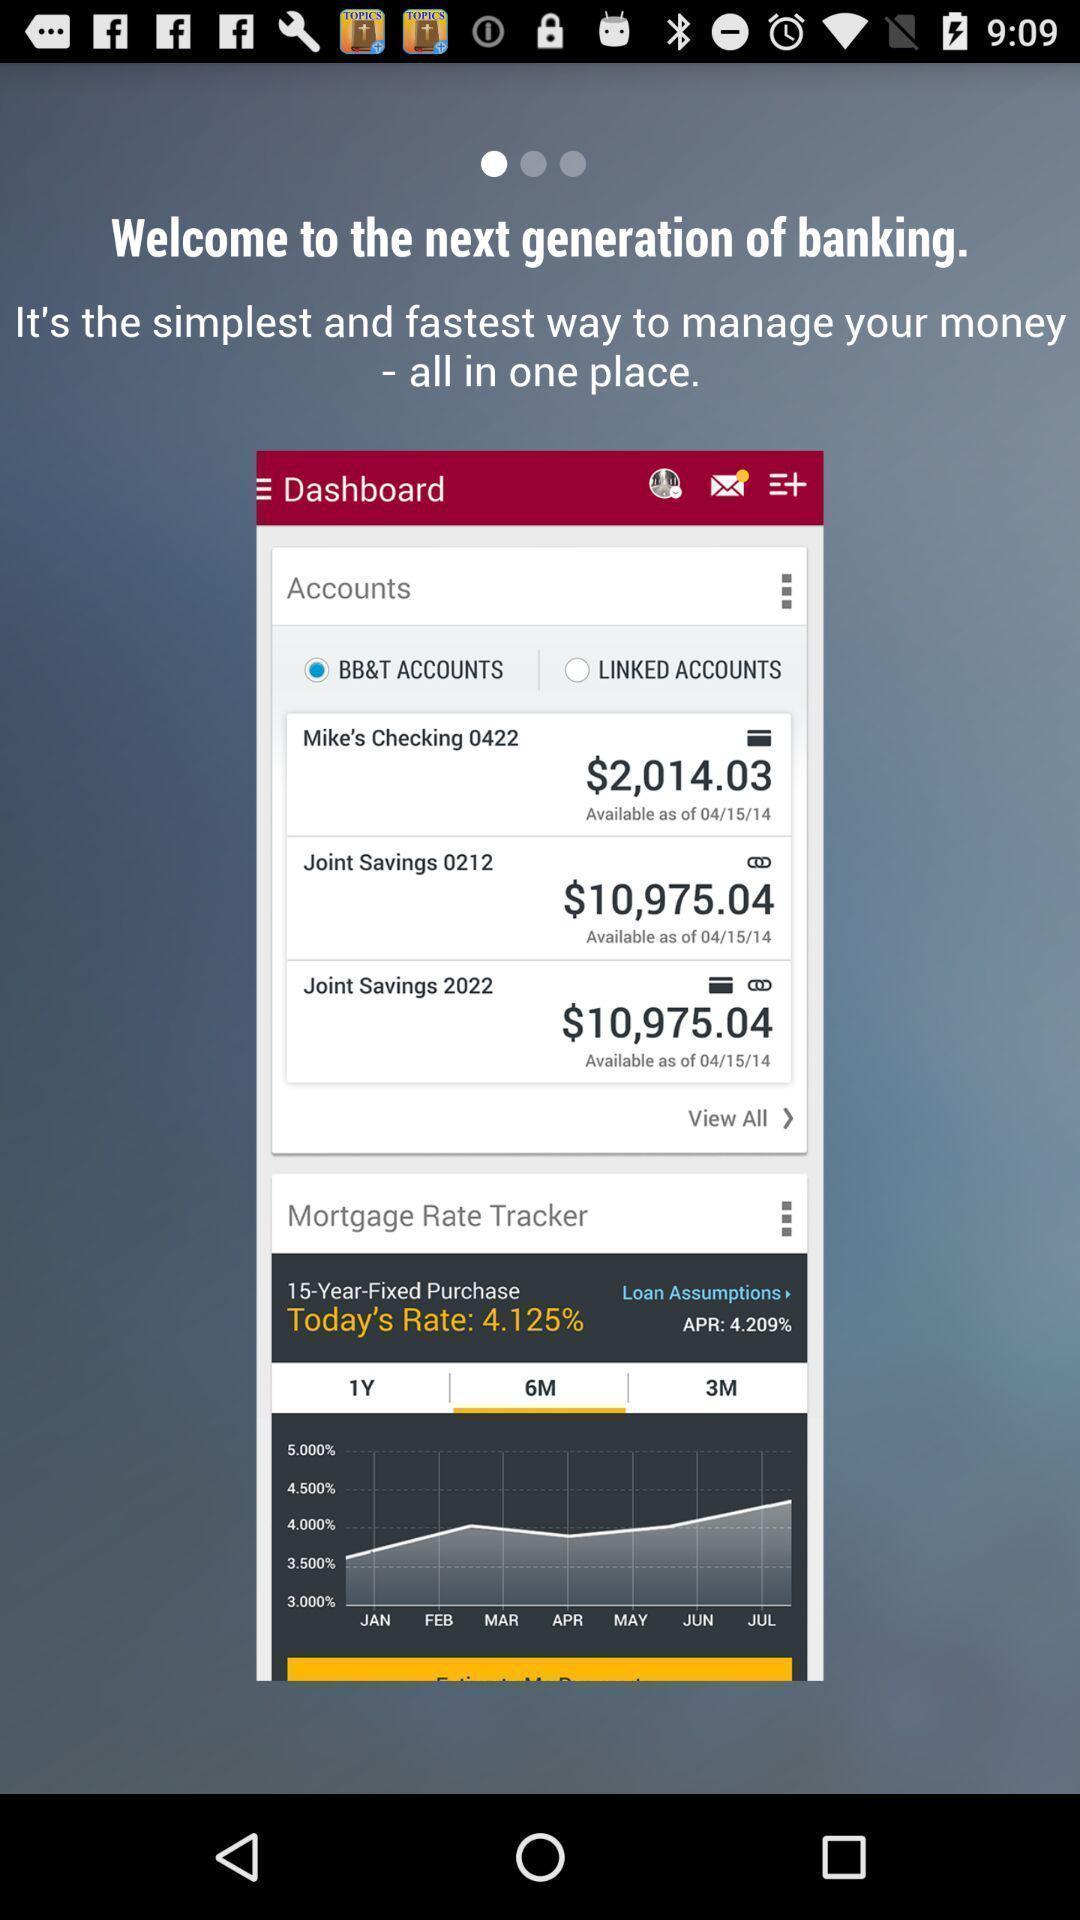Provide a description of this screenshot. Welcome page. 